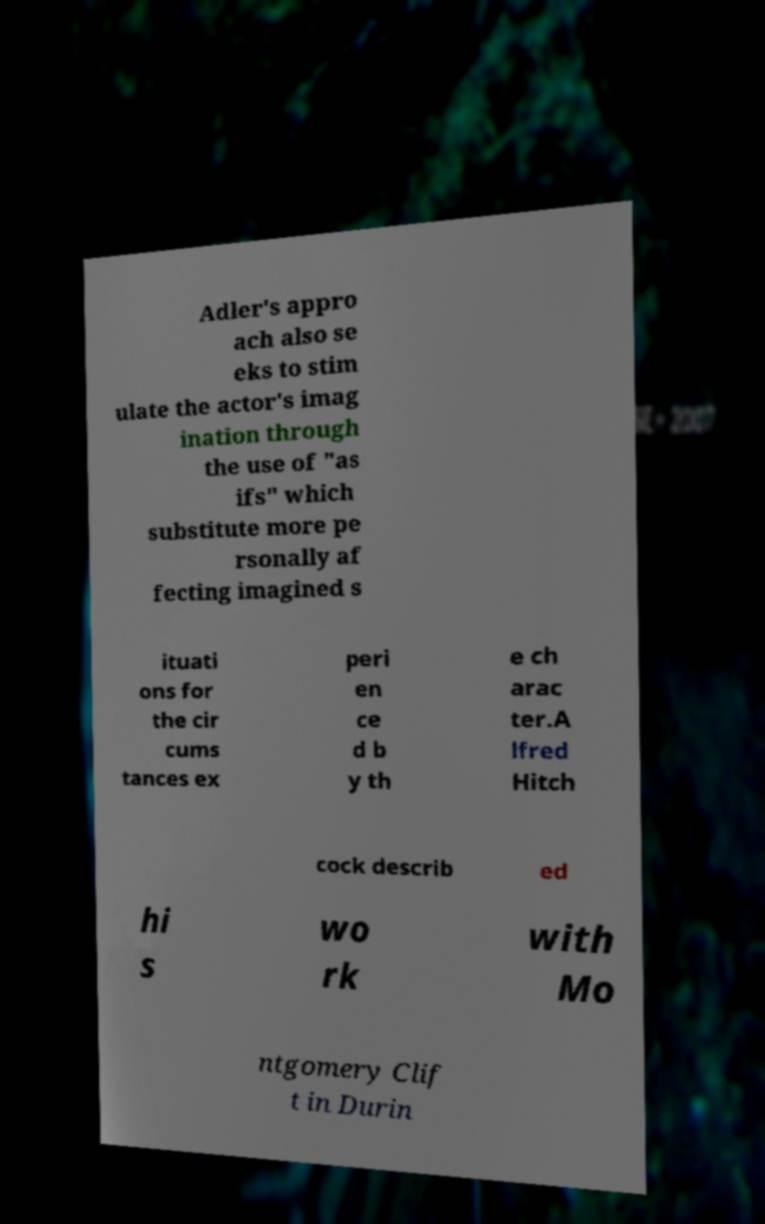Could you assist in decoding the text presented in this image and type it out clearly? Adler's appro ach also se eks to stim ulate the actor's imag ination through the use of "as ifs" which substitute more pe rsonally af fecting imagined s ituati ons for the cir cums tances ex peri en ce d b y th e ch arac ter.A lfred Hitch cock describ ed hi s wo rk with Mo ntgomery Clif t in Durin 